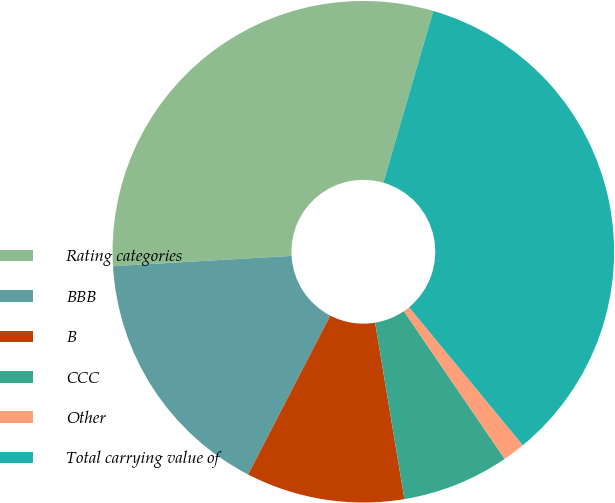Convert chart. <chart><loc_0><loc_0><loc_500><loc_500><pie_chart><fcel>Rating categories<fcel>BBB<fcel>B<fcel>CCC<fcel>Other<fcel>Total carrying value of<nl><fcel>30.42%<fcel>16.49%<fcel>10.22%<fcel>6.91%<fcel>1.44%<fcel>34.54%<nl></chart> 